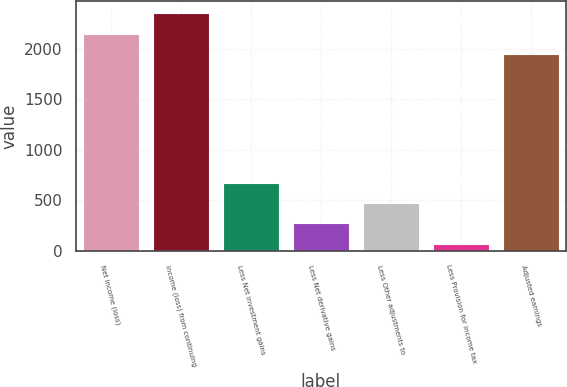Convert chart to OTSL. <chart><loc_0><loc_0><loc_500><loc_500><bar_chart><fcel>Net income (loss)<fcel>Income (loss) from continuing<fcel>Less Net investment gains<fcel>Less Net derivative gains<fcel>Less Other adjustments to<fcel>Less Provision for income tax<fcel>Adjusted earnings<nl><fcel>2147.8<fcel>2348.6<fcel>674.4<fcel>272.8<fcel>473.6<fcel>72<fcel>1947<nl></chart> 